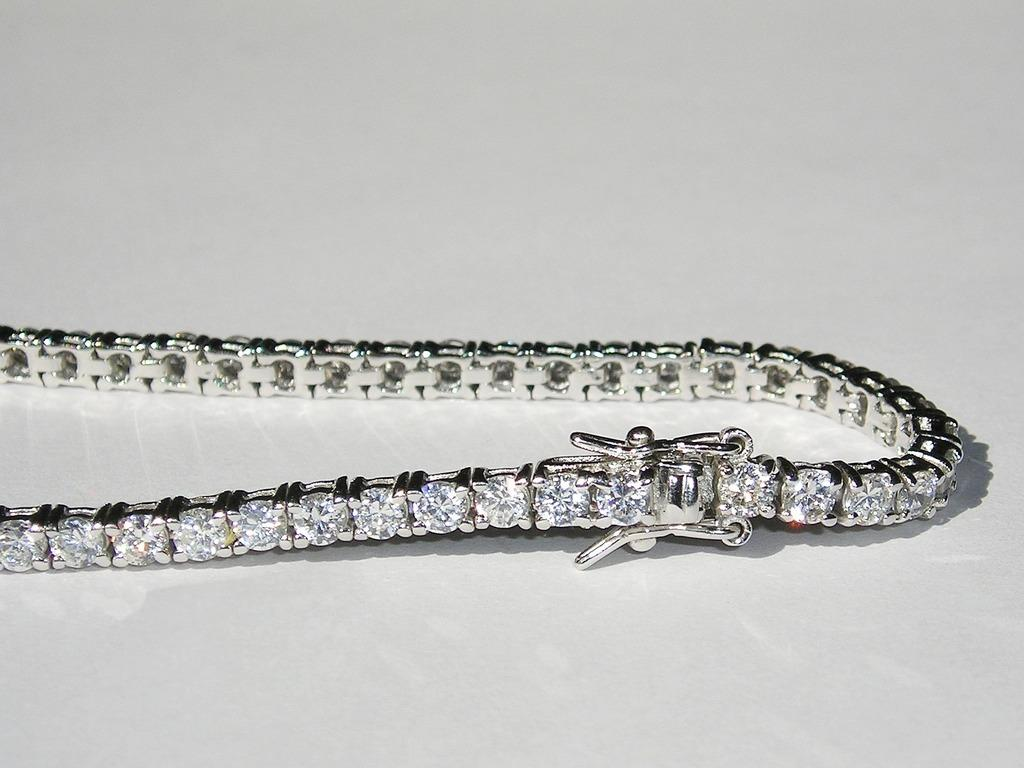What is the main subject of the picture? The main subject of the picture is an ornament. What is the ornament made of? The ornament is made of white color stones. What is the color of the surface on which the ornament is placed? The ornament is placed on a white surface. What time does the clock show in the image? There is no clock present in the image, so it is not possible to determine the time. 